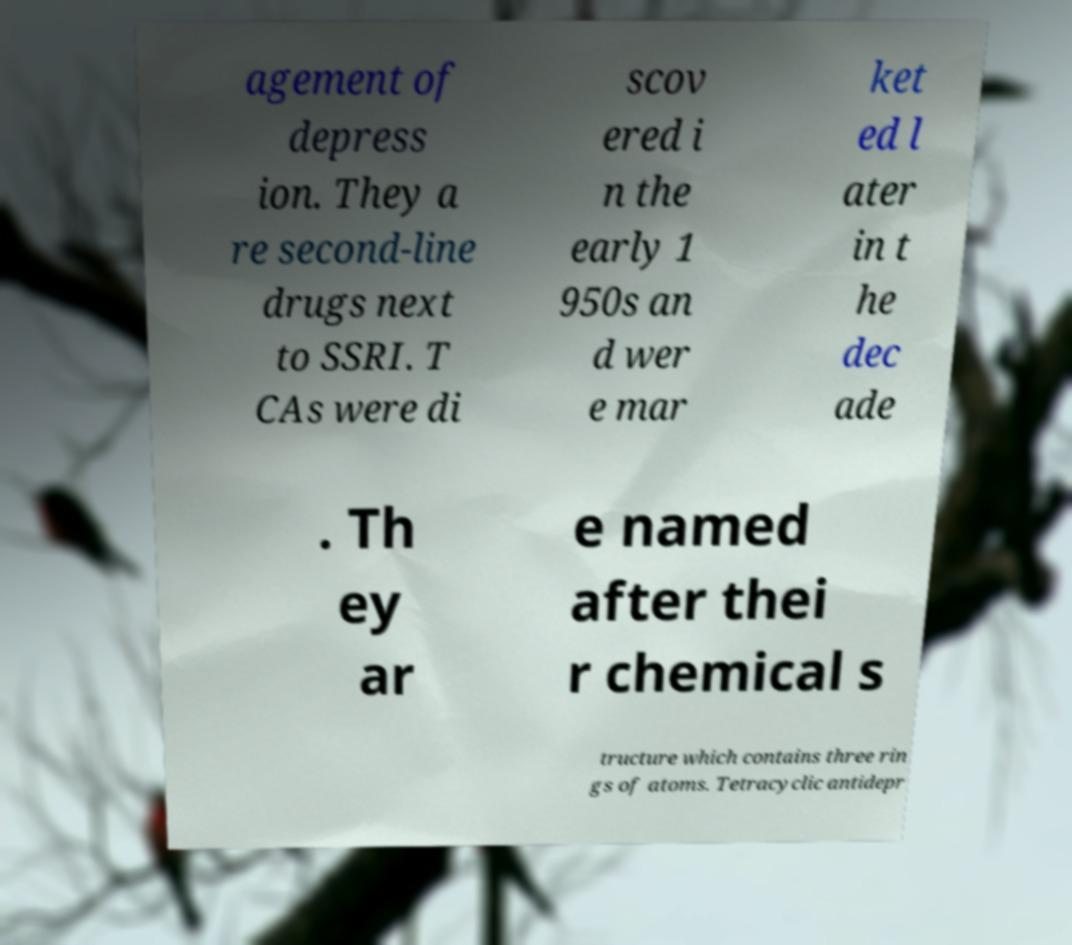For documentation purposes, I need the text within this image transcribed. Could you provide that? agement of depress ion. They a re second-line drugs next to SSRI. T CAs were di scov ered i n the early 1 950s an d wer e mar ket ed l ater in t he dec ade . Th ey ar e named after thei r chemical s tructure which contains three rin gs of atoms. Tetracyclic antidepr 